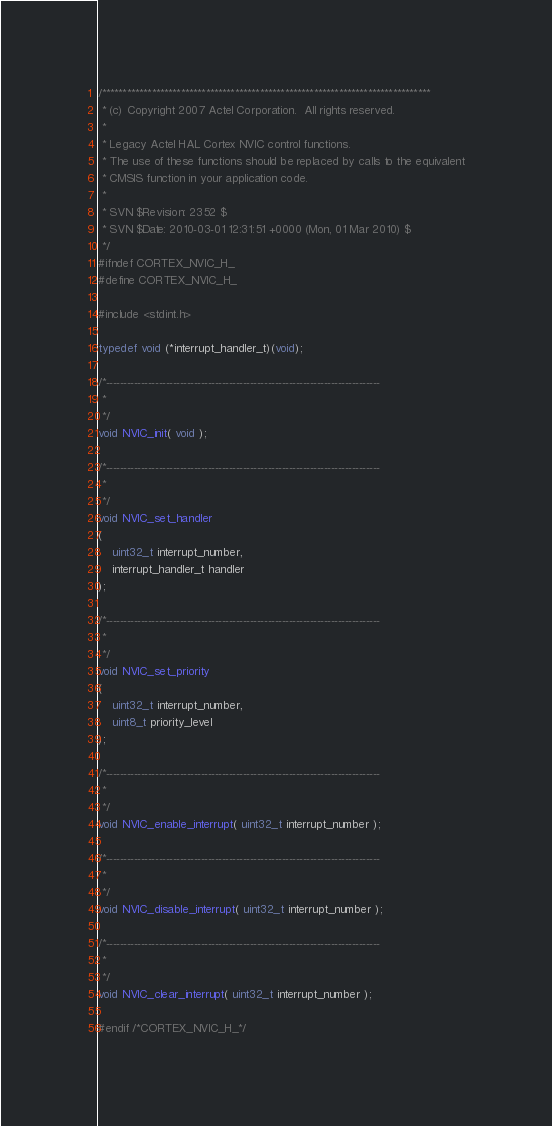<code> <loc_0><loc_0><loc_500><loc_500><_C_>/*******************************************************************************
 * (c) Copyright 2007 Actel Corporation.  All rights reserved.
 * 
 * Legacy Actel HAL Cortex NVIC control functions.
 * The use of these functions should be replaced by calls to the equivalent
 * CMSIS function in your application code.
 *
 * SVN $Revision: 2352 $
 * SVN $Date: 2010-03-01 12:31:51 +0000 (Mon, 01 Mar 2010) $
 */
#ifndef CORTEX_NVIC_H_
#define CORTEX_NVIC_H_

#include <stdint.h>

typedef void (*interrupt_handler_t)(void);

/*------------------------------------------------------------------------------
 * 
 */
void NVIC_init( void );

/*------------------------------------------------------------------------------
 * 
 */
void NVIC_set_handler
(
    uint32_t interrupt_number,
    interrupt_handler_t handler
);

/*------------------------------------------------------------------------------
 * 
 */
void NVIC_set_priority
(
    uint32_t interrupt_number,
    uint8_t priority_level
);

/*------------------------------------------------------------------------------
 * 
 */
void NVIC_enable_interrupt( uint32_t interrupt_number );

/*------------------------------------------------------------------------------
 * 
 */
void NVIC_disable_interrupt( uint32_t interrupt_number );

/*------------------------------------------------------------------------------
 * 
 */
void NVIC_clear_interrupt( uint32_t interrupt_number );

#endif /*CORTEX_NVIC_H_*/
</code> 